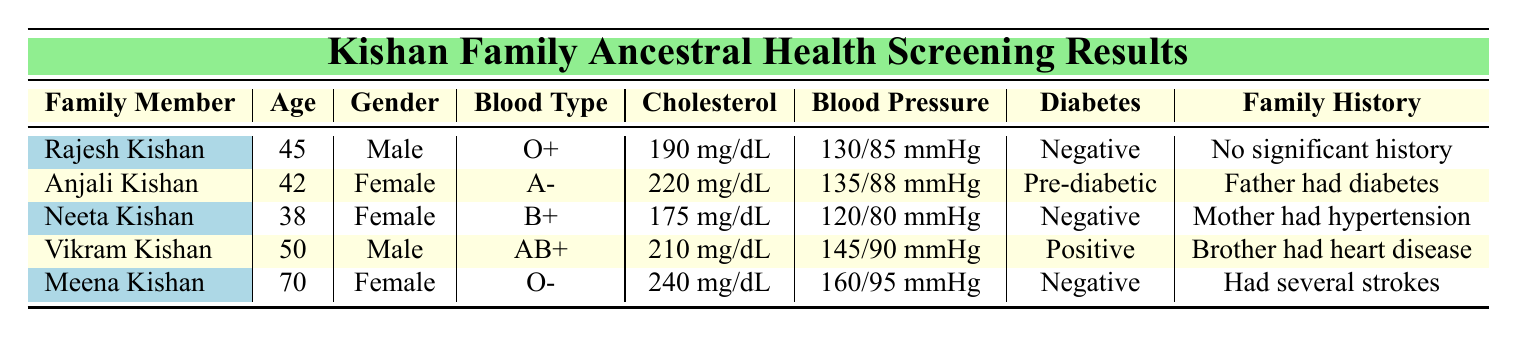What is the blood type of Rajesh Kishan? According to the table, Rajesh Kishan's blood type is listed in the Blood Type column. It is O+.
Answer: O+ How many family members are pre-diabetic? There is one family member with a pre-diabetic status, which can be found in the Diabetes Status column. Specifically, Anjali Kishan is marked as pre-diabetic.
Answer: 1 What is the average cholesterol level of the Kishan family members? To find the average cholesterol level, convert the cholesterol values from mg/dL into numbers: 190, 220, 175, 210, and 240. Adding them gives 1,035. There are 5 members, so the average is 1,035 / 5 = 207 mg/dL.
Answer: 207 mg/dL Does Meena Kishan have a family history of heart disease? Meena Kishan's family history is noted in the Family History column. It states "Had several strokes," which does not indicate heart disease. Thus, the answer is no.
Answer: No Which family member has the highest blood pressure? By comparing the blood pressure readings in the Blood Pressure column, Meena Kishan has the highest reading at 160/95 mmHg.
Answer: Meena Kishan What is the difference in cholesterol levels between Vikram Kishan and Neeta Kishan? Vikram Kishan has a cholesterol level of 210 mg/dL and Neeta Kishan has 175 mg/dL. The difference is calculated as 210 - 175 = 35 mg/dL.
Answer: 35 mg/dL Is there any family member with negative diabetes status who also has high blood pressure? Neeta Kishan is negative for diabetes and has a blood pressure of 120/80 mmHg (not high), while Meena Kishan is negative for diabetes and has high blood pressure (160/95 mmHg). Since Meena has high blood pressure and is negative for diabetes, the answer is yes.
Answer: Yes What percentage of family members have a family history of chronic illness? There are 5 family members, out of which 2 have family histories relating to chronic illnesses (Anjali and Meena). To find the percentage, compute (2 / 5) * 100 = 40%.
Answer: 40% 